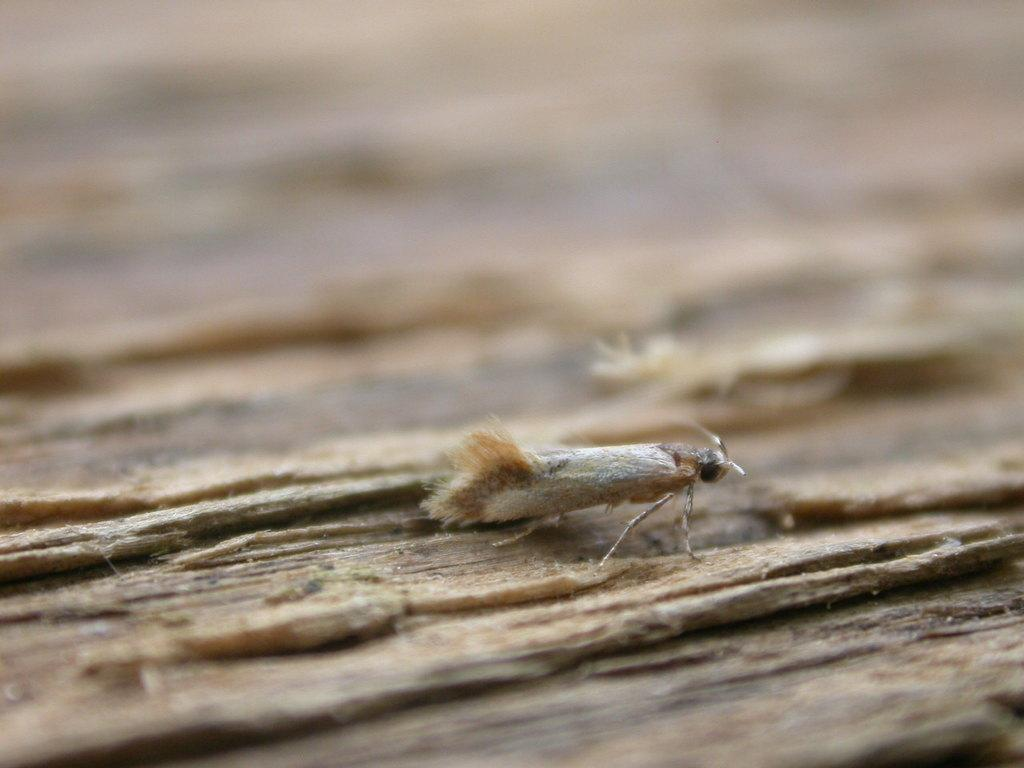What type of creature is present in the image? There is an insect in the image. What surface is the insect on? The insect is on a wooden object. Can you describe the background of the image? The background of the image is blurry. What type of stage can be seen in the background of the image? There is no stage present in the image; the background is blurry. 